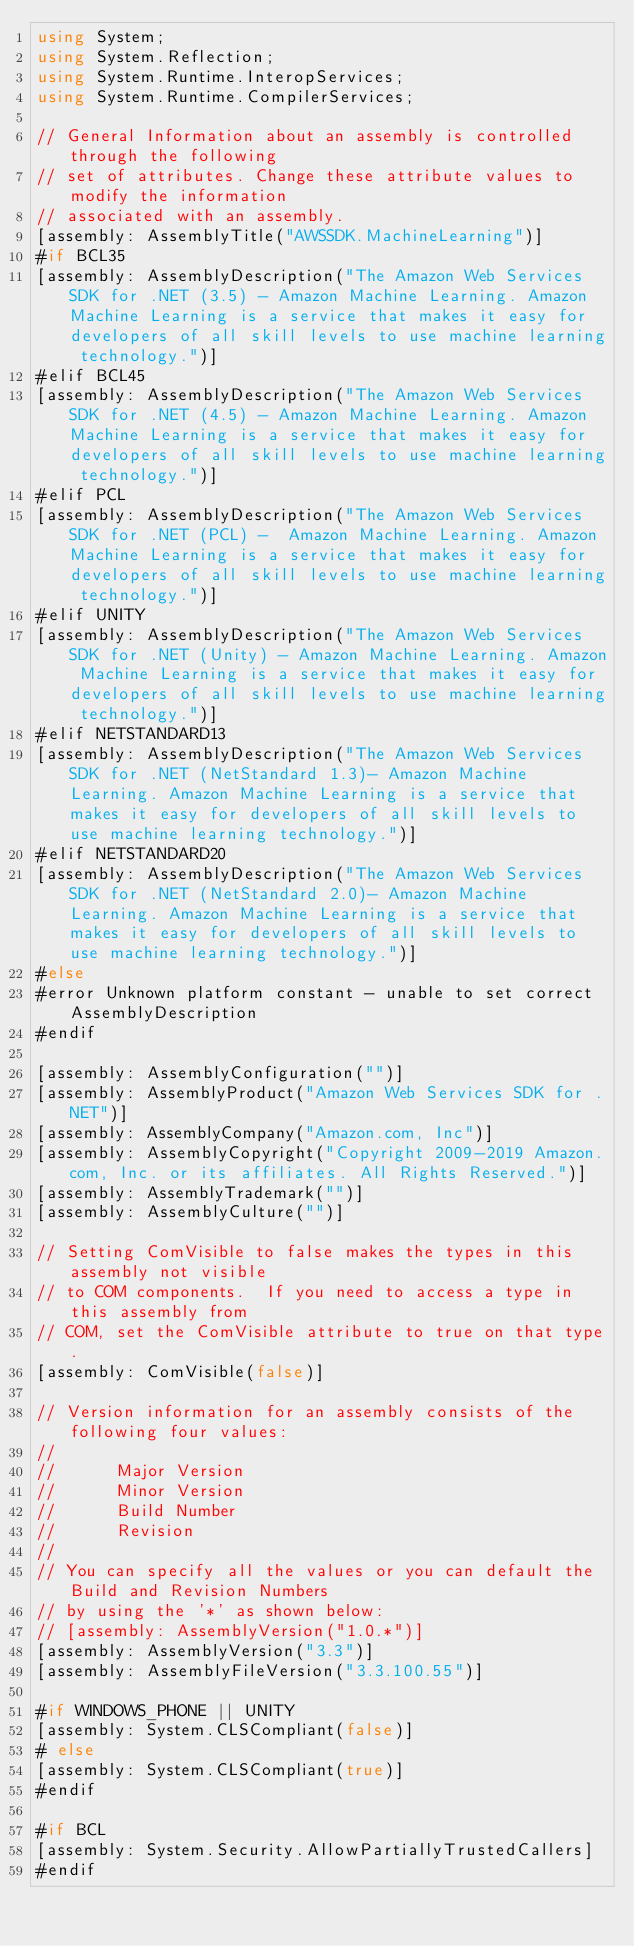<code> <loc_0><loc_0><loc_500><loc_500><_C#_>using System;
using System.Reflection;
using System.Runtime.InteropServices;
using System.Runtime.CompilerServices;

// General Information about an assembly is controlled through the following 
// set of attributes. Change these attribute values to modify the information
// associated with an assembly.
[assembly: AssemblyTitle("AWSSDK.MachineLearning")]
#if BCL35
[assembly: AssemblyDescription("The Amazon Web Services SDK for .NET (3.5) - Amazon Machine Learning. Amazon Machine Learning is a service that makes it easy for developers of all skill levels to use machine learning technology.")]
#elif BCL45
[assembly: AssemblyDescription("The Amazon Web Services SDK for .NET (4.5) - Amazon Machine Learning. Amazon Machine Learning is a service that makes it easy for developers of all skill levels to use machine learning technology.")]
#elif PCL
[assembly: AssemblyDescription("The Amazon Web Services SDK for .NET (PCL) -  Amazon Machine Learning. Amazon Machine Learning is a service that makes it easy for developers of all skill levels to use machine learning technology.")]
#elif UNITY
[assembly: AssemblyDescription("The Amazon Web Services SDK for .NET (Unity) - Amazon Machine Learning. Amazon Machine Learning is a service that makes it easy for developers of all skill levels to use machine learning technology.")]
#elif NETSTANDARD13
[assembly: AssemblyDescription("The Amazon Web Services SDK for .NET (NetStandard 1.3)- Amazon Machine Learning. Amazon Machine Learning is a service that makes it easy for developers of all skill levels to use machine learning technology.")]
#elif NETSTANDARD20
[assembly: AssemblyDescription("The Amazon Web Services SDK for .NET (NetStandard 2.0)- Amazon Machine Learning. Amazon Machine Learning is a service that makes it easy for developers of all skill levels to use machine learning technology.")]
#else
#error Unknown platform constant - unable to set correct AssemblyDescription
#endif

[assembly: AssemblyConfiguration("")]
[assembly: AssemblyProduct("Amazon Web Services SDK for .NET")]
[assembly: AssemblyCompany("Amazon.com, Inc")]
[assembly: AssemblyCopyright("Copyright 2009-2019 Amazon.com, Inc. or its affiliates. All Rights Reserved.")]
[assembly: AssemblyTrademark("")]
[assembly: AssemblyCulture("")]

// Setting ComVisible to false makes the types in this assembly not visible 
// to COM components.  If you need to access a type in this assembly from 
// COM, set the ComVisible attribute to true on that type.
[assembly: ComVisible(false)]

// Version information for an assembly consists of the following four values:
//
//      Major Version
//      Minor Version 
//      Build Number
//      Revision
//
// You can specify all the values or you can default the Build and Revision Numbers 
// by using the '*' as shown below:
// [assembly: AssemblyVersion("1.0.*")]
[assembly: AssemblyVersion("3.3")]
[assembly: AssemblyFileVersion("3.3.100.55")]

#if WINDOWS_PHONE || UNITY
[assembly: System.CLSCompliant(false)]
# else
[assembly: System.CLSCompliant(true)]
#endif

#if BCL
[assembly: System.Security.AllowPartiallyTrustedCallers]
#endif</code> 